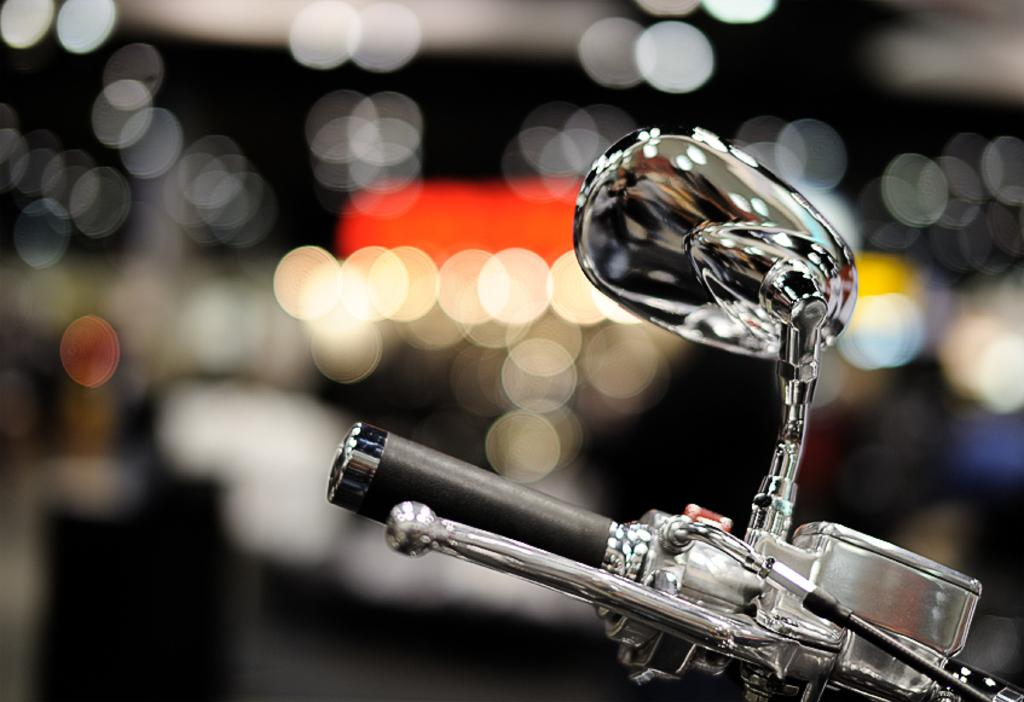What object in the image reflects light? There is a mirror in the image that reflects light. What type of vehicle might the handle belong to? The handle in the image is likely from a vehicle, but the specific type cannot be determined from the image. How would you describe the background of the image? The background of the image is blurry. How many beds can be seen in the image? There are no beds present in the image. What type of print is visible on the mirror in the image? There is no print visible on the mirror in the image. 